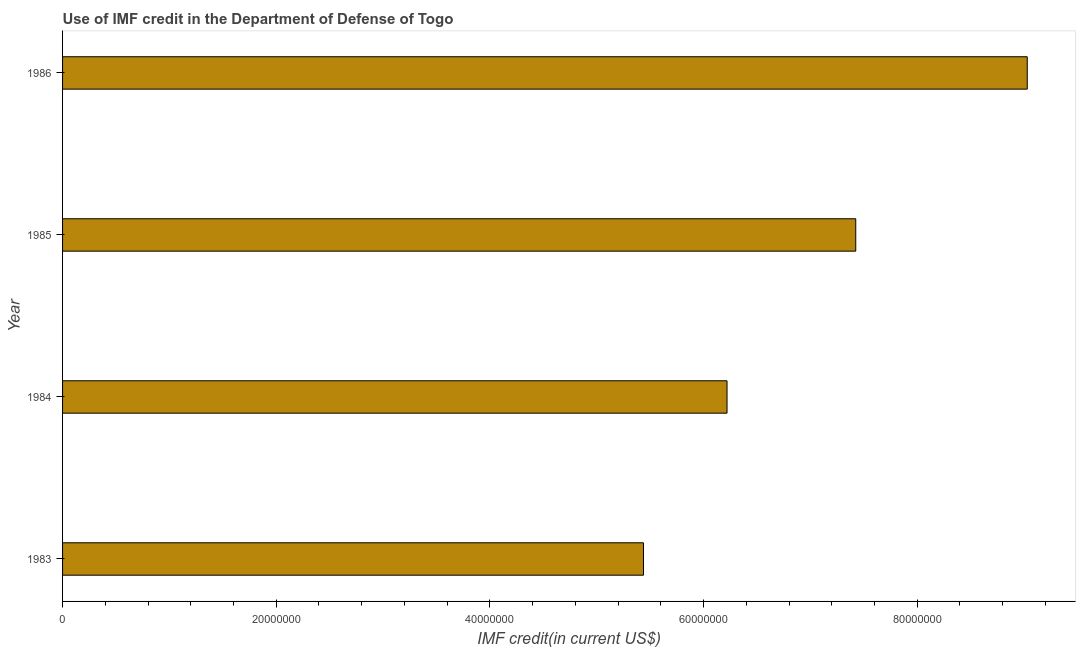What is the title of the graph?
Provide a succinct answer. Use of IMF credit in the Department of Defense of Togo. What is the label or title of the X-axis?
Your response must be concise. IMF credit(in current US$). What is the label or title of the Y-axis?
Offer a very short reply. Year. What is the use of imf credit in dod in 1985?
Your answer should be very brief. 7.42e+07. Across all years, what is the maximum use of imf credit in dod?
Your answer should be compact. 9.03e+07. Across all years, what is the minimum use of imf credit in dod?
Your answer should be very brief. 5.44e+07. In which year was the use of imf credit in dod minimum?
Your answer should be compact. 1983. What is the sum of the use of imf credit in dod?
Your answer should be very brief. 2.81e+08. What is the difference between the use of imf credit in dod in 1983 and 1986?
Provide a short and direct response. -3.59e+07. What is the average use of imf credit in dod per year?
Your answer should be compact. 7.03e+07. What is the median use of imf credit in dod?
Your answer should be very brief. 6.82e+07. Do a majority of the years between 1986 and 1985 (inclusive) have use of imf credit in dod greater than 28000000 US$?
Offer a very short reply. No. What is the ratio of the use of imf credit in dod in 1983 to that in 1985?
Your answer should be compact. 0.73. Is the use of imf credit in dod in 1984 less than that in 1986?
Your response must be concise. Yes. What is the difference between the highest and the second highest use of imf credit in dod?
Provide a succinct answer. 1.61e+07. What is the difference between the highest and the lowest use of imf credit in dod?
Make the answer very short. 3.59e+07. In how many years, is the use of imf credit in dod greater than the average use of imf credit in dod taken over all years?
Your answer should be very brief. 2. How many bars are there?
Provide a succinct answer. 4. Are all the bars in the graph horizontal?
Give a very brief answer. Yes. What is the difference between two consecutive major ticks on the X-axis?
Offer a very short reply. 2.00e+07. What is the IMF credit(in current US$) in 1983?
Keep it short and to the point. 5.44e+07. What is the IMF credit(in current US$) in 1984?
Your answer should be compact. 6.22e+07. What is the IMF credit(in current US$) of 1985?
Your answer should be very brief. 7.42e+07. What is the IMF credit(in current US$) in 1986?
Make the answer very short. 9.03e+07. What is the difference between the IMF credit(in current US$) in 1983 and 1984?
Offer a very short reply. -7.82e+06. What is the difference between the IMF credit(in current US$) in 1983 and 1985?
Make the answer very short. -1.99e+07. What is the difference between the IMF credit(in current US$) in 1983 and 1986?
Your response must be concise. -3.59e+07. What is the difference between the IMF credit(in current US$) in 1984 and 1985?
Offer a very short reply. -1.20e+07. What is the difference between the IMF credit(in current US$) in 1984 and 1986?
Give a very brief answer. -2.81e+07. What is the difference between the IMF credit(in current US$) in 1985 and 1986?
Ensure brevity in your answer.  -1.61e+07. What is the ratio of the IMF credit(in current US$) in 1983 to that in 1984?
Your answer should be compact. 0.87. What is the ratio of the IMF credit(in current US$) in 1983 to that in 1985?
Offer a terse response. 0.73. What is the ratio of the IMF credit(in current US$) in 1983 to that in 1986?
Make the answer very short. 0.6. What is the ratio of the IMF credit(in current US$) in 1984 to that in 1985?
Provide a succinct answer. 0.84. What is the ratio of the IMF credit(in current US$) in 1984 to that in 1986?
Offer a very short reply. 0.69. What is the ratio of the IMF credit(in current US$) in 1985 to that in 1986?
Provide a succinct answer. 0.82. 